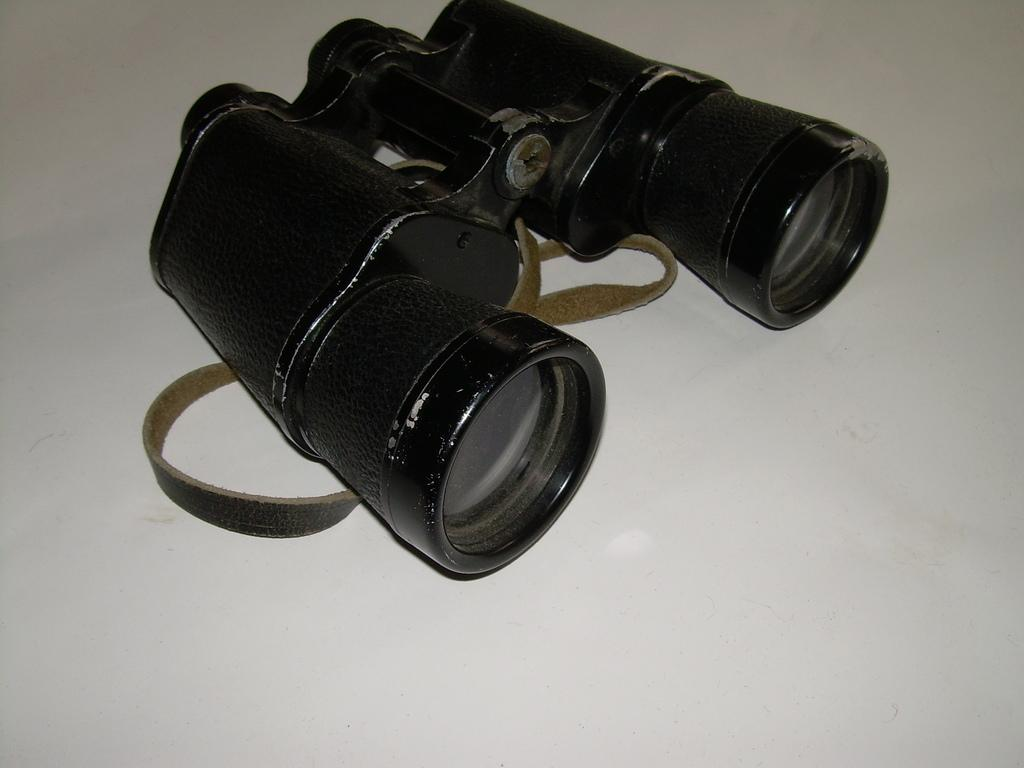What is the main object in the image? There is a binocular in the image. What is the color of the binocular? The binocular is black in color. What is the color of the surface the binocular is on? The surface the binocular is on is white in color. What type of voyage or trip is the binocular being used for in the image? The image does not provide any information about a voyage or trip, nor does it show the binocular being used for any specific purpose. Where is the binocular being used in a park? The image does not show the binocular being used in a park or any other specific location. 